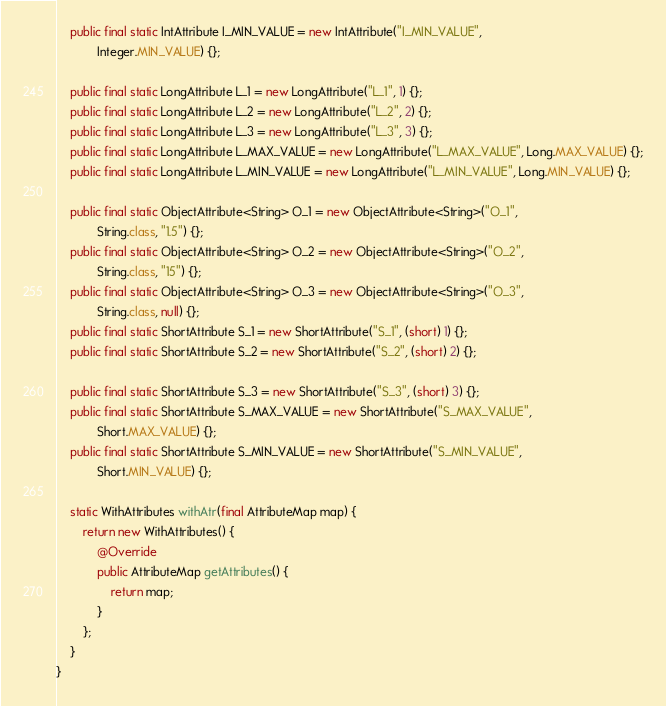Convert code to text. <code><loc_0><loc_0><loc_500><loc_500><_Java_>    public final static IntAttribute I_MIN_VALUE = new IntAttribute("I_MIN_VALUE",
            Integer.MIN_VALUE) {};

    public final static LongAttribute L_1 = new LongAttribute("L_1", 1) {};
    public final static LongAttribute L_2 = new LongAttribute("L_2", 2) {};
    public final static LongAttribute L_3 = new LongAttribute("L_3", 3) {};
    public final static LongAttribute L_MAX_VALUE = new LongAttribute("L_MAX_VALUE", Long.MAX_VALUE) {};
    public final static LongAttribute L_MIN_VALUE = new LongAttribute("L_MIN_VALUE", Long.MIN_VALUE) {};

    public final static ObjectAttribute<String> O_1 = new ObjectAttribute<String>("O_1",
            String.class, "1.5") {};
    public final static ObjectAttribute<String> O_2 = new ObjectAttribute<String>("O_2",
            String.class, "15") {};
    public final static ObjectAttribute<String> O_3 = new ObjectAttribute<String>("O_3",
            String.class, null) {};
    public final static ShortAttribute S_1 = new ShortAttribute("S_1", (short) 1) {};
    public final static ShortAttribute S_2 = new ShortAttribute("S_2", (short) 2) {};

    public final static ShortAttribute S_3 = new ShortAttribute("S_3", (short) 3) {};
    public final static ShortAttribute S_MAX_VALUE = new ShortAttribute("S_MAX_VALUE",
            Short.MAX_VALUE) {};
    public final static ShortAttribute S_MIN_VALUE = new ShortAttribute("S_MIN_VALUE",
            Short.MIN_VALUE) {};

    static WithAttributes withAtr(final AttributeMap map) {
        return new WithAttributes() {
            @Override
            public AttributeMap getAttributes() {
                return map;
            }
        };
    }
}
</code> 